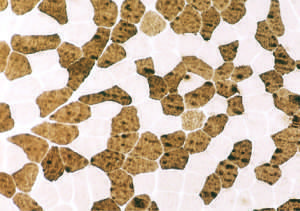what did fibers on this atpase reaction ph9 .4 correspond to?
Answer the question using a single word or phrase. Findings in fig711 